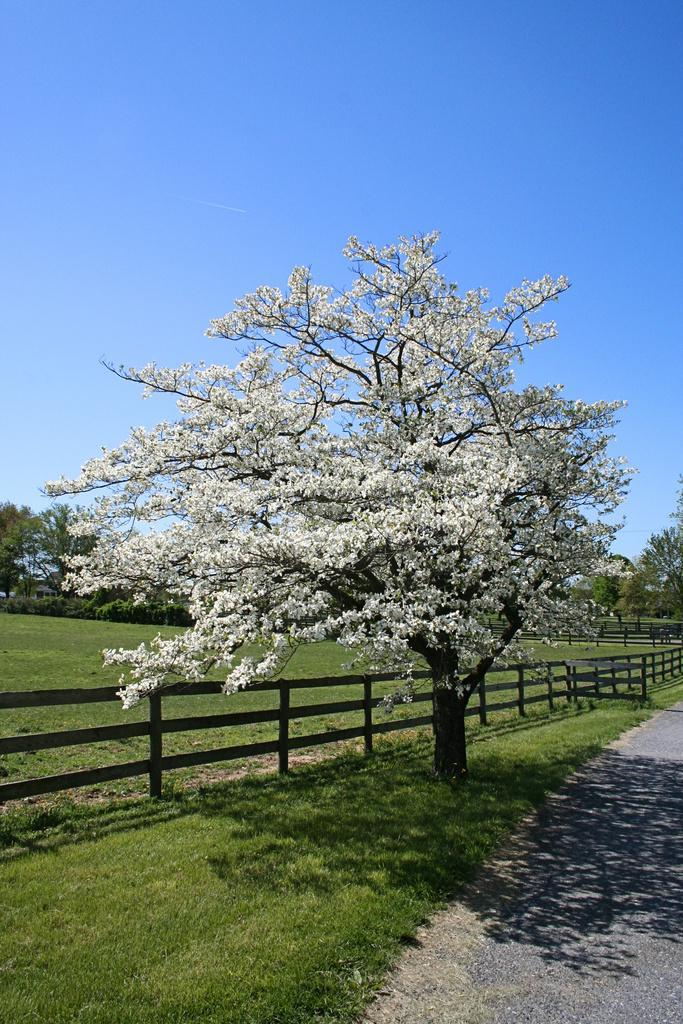Could you give a brief overview of what you see in this image? In the image we can see a tree, fence, road, grass and a sky. 